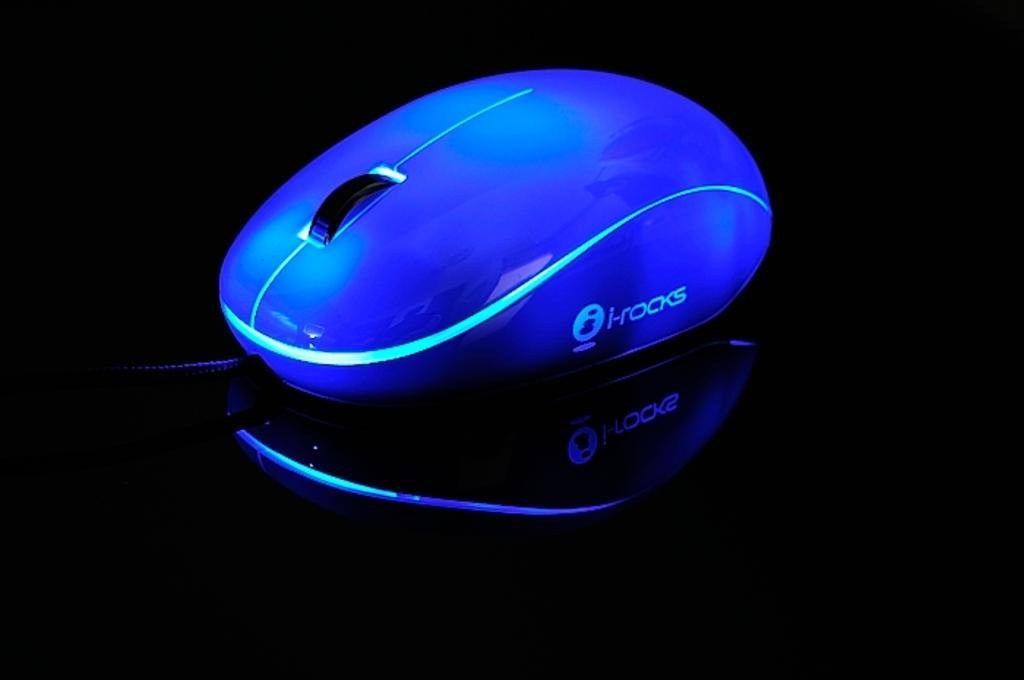What type of animal is present in the image? There is a mouse in the image. What color is the surface on which the mouse is located? The mouse is on a black color surface. How many chickens are present in the image? There are no chickens present in the image; it features a mouse on a black surface. What type of fruit is being held by the mouse in the image? There is no fruit, such as a cherry, present in the image. 